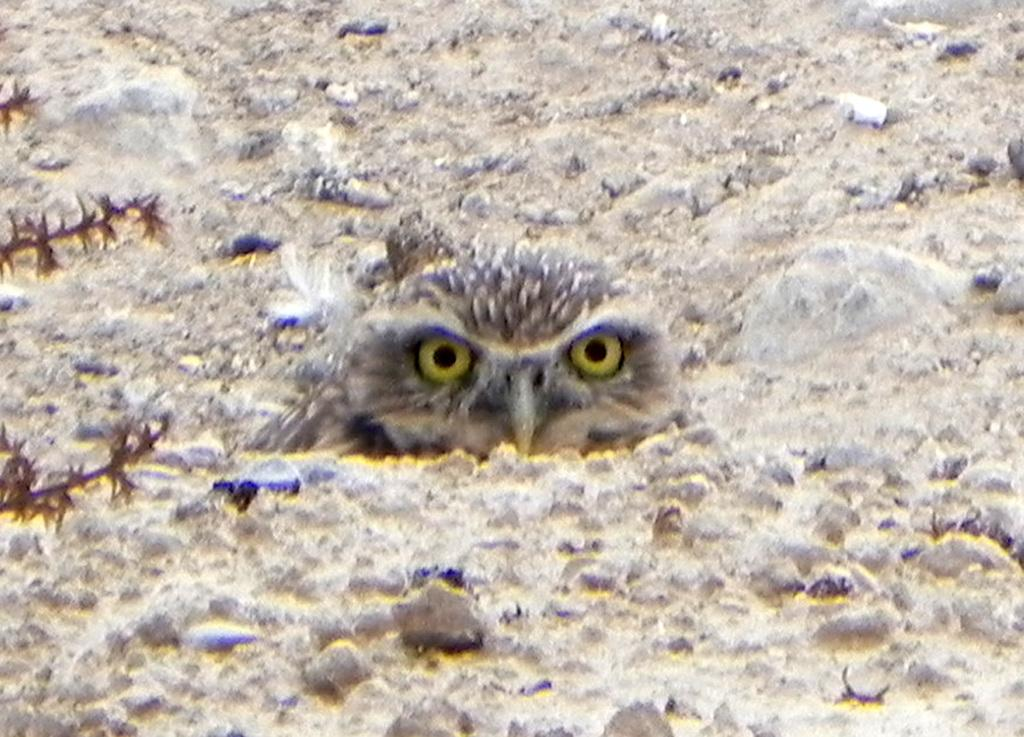What is the main subject of the image? There is an owl in the center of the image. What type of lace is being used by the carpenter in the image? There is no carpenter or lace present in the image; it features an owl. How many birds are visible in the image? There is only one bird visible in the image, which is the owl. 